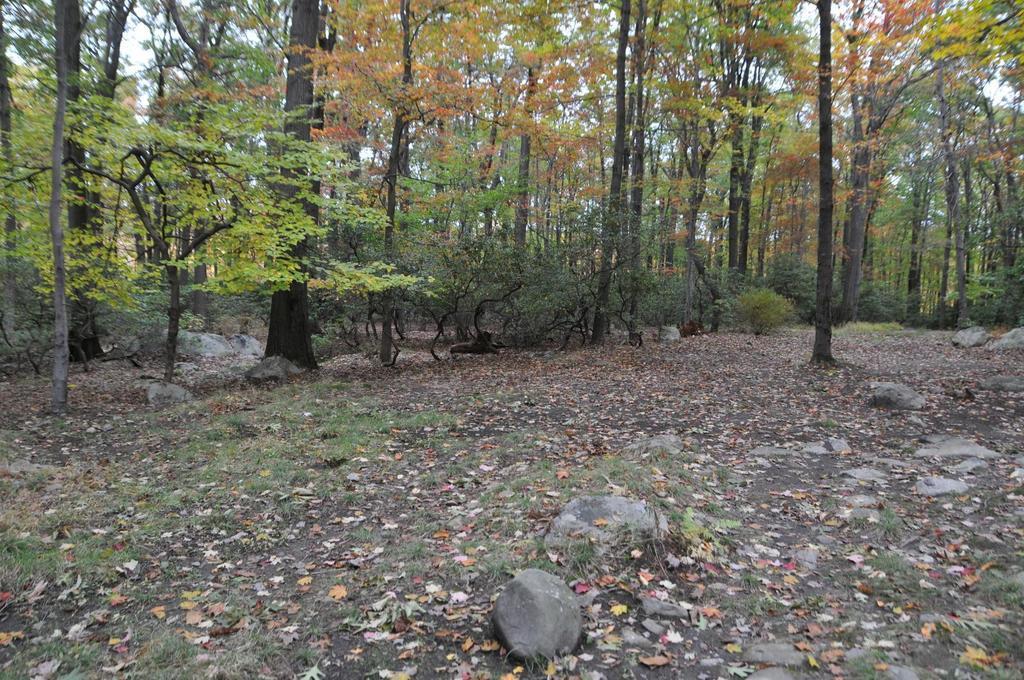Can you describe this image briefly? These are the trees with branches and leaves. I can see the rocks and dried leaves lying on the ground. This is the grass. 